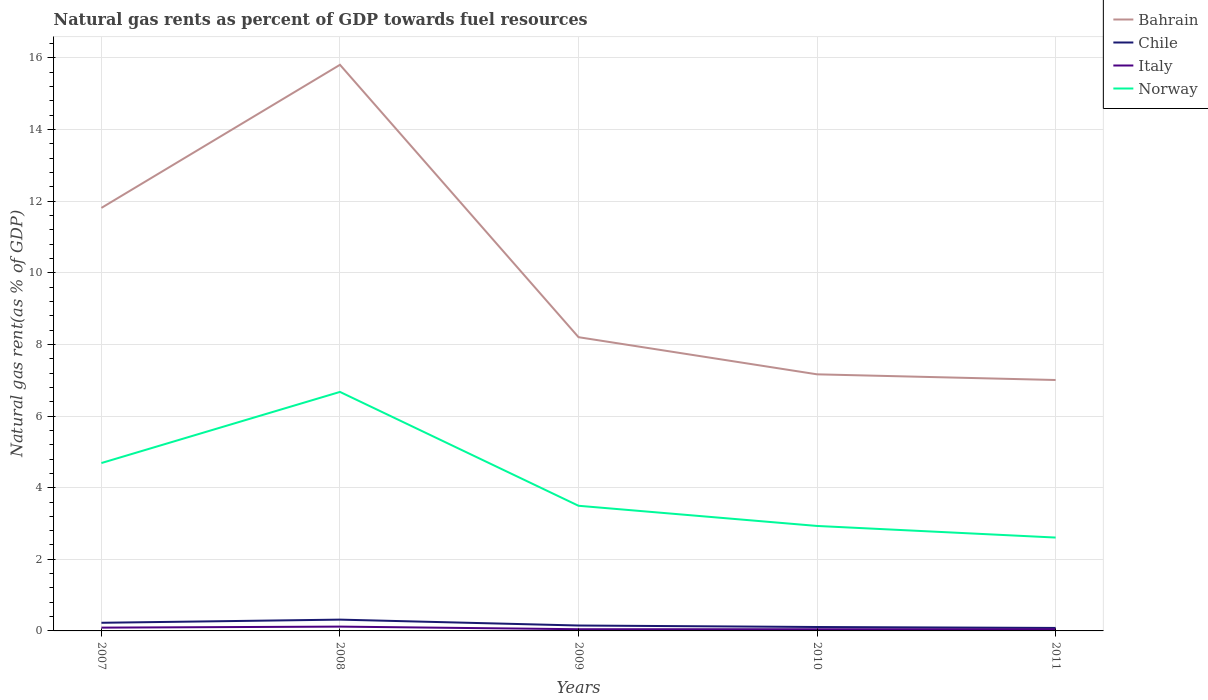Does the line corresponding to Italy intersect with the line corresponding to Bahrain?
Offer a terse response. No. Across all years, what is the maximum natural gas rent in Chile?
Offer a terse response. 0.08. In which year was the natural gas rent in Norway maximum?
Offer a terse response. 2011. What is the total natural gas rent in Chile in the graph?
Offer a terse response. 0.14. What is the difference between the highest and the second highest natural gas rent in Norway?
Give a very brief answer. 4.07. Is the natural gas rent in Chile strictly greater than the natural gas rent in Italy over the years?
Give a very brief answer. No. How many lines are there?
Keep it short and to the point. 4. Are the values on the major ticks of Y-axis written in scientific E-notation?
Your answer should be very brief. No. Does the graph contain any zero values?
Make the answer very short. No. Does the graph contain grids?
Your response must be concise. Yes. How are the legend labels stacked?
Make the answer very short. Vertical. What is the title of the graph?
Give a very brief answer. Natural gas rents as percent of GDP towards fuel resources. What is the label or title of the Y-axis?
Your response must be concise. Natural gas rent(as % of GDP). What is the Natural gas rent(as % of GDP) of Bahrain in 2007?
Your answer should be compact. 11.81. What is the Natural gas rent(as % of GDP) in Chile in 2007?
Your answer should be compact. 0.23. What is the Natural gas rent(as % of GDP) of Italy in 2007?
Offer a terse response. 0.09. What is the Natural gas rent(as % of GDP) of Norway in 2007?
Your answer should be compact. 4.69. What is the Natural gas rent(as % of GDP) of Bahrain in 2008?
Provide a succinct answer. 15.81. What is the Natural gas rent(as % of GDP) of Chile in 2008?
Give a very brief answer. 0.32. What is the Natural gas rent(as % of GDP) in Italy in 2008?
Keep it short and to the point. 0.12. What is the Natural gas rent(as % of GDP) of Norway in 2008?
Provide a succinct answer. 6.67. What is the Natural gas rent(as % of GDP) in Bahrain in 2009?
Give a very brief answer. 8.2. What is the Natural gas rent(as % of GDP) of Chile in 2009?
Your response must be concise. 0.15. What is the Natural gas rent(as % of GDP) of Italy in 2009?
Your response must be concise. 0.05. What is the Natural gas rent(as % of GDP) in Norway in 2009?
Make the answer very short. 3.49. What is the Natural gas rent(as % of GDP) in Bahrain in 2010?
Offer a very short reply. 7.17. What is the Natural gas rent(as % of GDP) in Chile in 2010?
Keep it short and to the point. 0.11. What is the Natural gas rent(as % of GDP) of Italy in 2010?
Provide a short and direct response. 0.05. What is the Natural gas rent(as % of GDP) in Norway in 2010?
Your response must be concise. 2.93. What is the Natural gas rent(as % of GDP) in Bahrain in 2011?
Ensure brevity in your answer.  7.01. What is the Natural gas rent(as % of GDP) of Chile in 2011?
Keep it short and to the point. 0.08. What is the Natural gas rent(as % of GDP) in Italy in 2011?
Your answer should be very brief. 0.05. What is the Natural gas rent(as % of GDP) of Norway in 2011?
Offer a very short reply. 2.61. Across all years, what is the maximum Natural gas rent(as % of GDP) in Bahrain?
Offer a terse response. 15.81. Across all years, what is the maximum Natural gas rent(as % of GDP) in Chile?
Ensure brevity in your answer.  0.32. Across all years, what is the maximum Natural gas rent(as % of GDP) of Italy?
Your answer should be very brief. 0.12. Across all years, what is the maximum Natural gas rent(as % of GDP) of Norway?
Your answer should be compact. 6.67. Across all years, what is the minimum Natural gas rent(as % of GDP) in Bahrain?
Your answer should be compact. 7.01. Across all years, what is the minimum Natural gas rent(as % of GDP) of Chile?
Your answer should be compact. 0.08. Across all years, what is the minimum Natural gas rent(as % of GDP) in Italy?
Ensure brevity in your answer.  0.05. Across all years, what is the minimum Natural gas rent(as % of GDP) of Norway?
Ensure brevity in your answer.  2.61. What is the total Natural gas rent(as % of GDP) of Bahrain in the graph?
Provide a short and direct response. 50. What is the total Natural gas rent(as % of GDP) of Chile in the graph?
Ensure brevity in your answer.  0.89. What is the total Natural gas rent(as % of GDP) of Italy in the graph?
Your answer should be compact. 0.35. What is the total Natural gas rent(as % of GDP) in Norway in the graph?
Your answer should be very brief. 20.4. What is the difference between the Natural gas rent(as % of GDP) in Bahrain in 2007 and that in 2008?
Keep it short and to the point. -4. What is the difference between the Natural gas rent(as % of GDP) in Chile in 2007 and that in 2008?
Keep it short and to the point. -0.09. What is the difference between the Natural gas rent(as % of GDP) of Italy in 2007 and that in 2008?
Keep it short and to the point. -0.03. What is the difference between the Natural gas rent(as % of GDP) of Norway in 2007 and that in 2008?
Your answer should be very brief. -1.99. What is the difference between the Natural gas rent(as % of GDP) of Bahrain in 2007 and that in 2009?
Your answer should be compact. 3.61. What is the difference between the Natural gas rent(as % of GDP) of Chile in 2007 and that in 2009?
Make the answer very short. 0.08. What is the difference between the Natural gas rent(as % of GDP) of Italy in 2007 and that in 2009?
Your answer should be compact. 0.04. What is the difference between the Natural gas rent(as % of GDP) in Norway in 2007 and that in 2009?
Ensure brevity in your answer.  1.19. What is the difference between the Natural gas rent(as % of GDP) of Bahrain in 2007 and that in 2010?
Your answer should be compact. 4.65. What is the difference between the Natural gas rent(as % of GDP) in Chile in 2007 and that in 2010?
Give a very brief answer. 0.12. What is the difference between the Natural gas rent(as % of GDP) in Italy in 2007 and that in 2010?
Provide a succinct answer. 0.05. What is the difference between the Natural gas rent(as % of GDP) of Norway in 2007 and that in 2010?
Your answer should be compact. 1.76. What is the difference between the Natural gas rent(as % of GDP) of Bahrain in 2007 and that in 2011?
Keep it short and to the point. 4.81. What is the difference between the Natural gas rent(as % of GDP) in Chile in 2007 and that in 2011?
Provide a succinct answer. 0.14. What is the difference between the Natural gas rent(as % of GDP) of Italy in 2007 and that in 2011?
Your answer should be compact. 0.04. What is the difference between the Natural gas rent(as % of GDP) in Norway in 2007 and that in 2011?
Offer a very short reply. 2.08. What is the difference between the Natural gas rent(as % of GDP) in Bahrain in 2008 and that in 2009?
Your response must be concise. 7.61. What is the difference between the Natural gas rent(as % of GDP) of Chile in 2008 and that in 2009?
Give a very brief answer. 0.16. What is the difference between the Natural gas rent(as % of GDP) in Italy in 2008 and that in 2009?
Keep it short and to the point. 0.07. What is the difference between the Natural gas rent(as % of GDP) in Norway in 2008 and that in 2009?
Provide a short and direct response. 3.18. What is the difference between the Natural gas rent(as % of GDP) of Bahrain in 2008 and that in 2010?
Ensure brevity in your answer.  8.64. What is the difference between the Natural gas rent(as % of GDP) of Chile in 2008 and that in 2010?
Ensure brevity in your answer.  0.21. What is the difference between the Natural gas rent(as % of GDP) in Italy in 2008 and that in 2010?
Keep it short and to the point. 0.07. What is the difference between the Natural gas rent(as % of GDP) in Norway in 2008 and that in 2010?
Make the answer very short. 3.74. What is the difference between the Natural gas rent(as % of GDP) of Bahrain in 2008 and that in 2011?
Provide a succinct answer. 8.8. What is the difference between the Natural gas rent(as % of GDP) of Chile in 2008 and that in 2011?
Offer a terse response. 0.23. What is the difference between the Natural gas rent(as % of GDP) of Italy in 2008 and that in 2011?
Provide a short and direct response. 0.07. What is the difference between the Natural gas rent(as % of GDP) of Norway in 2008 and that in 2011?
Provide a short and direct response. 4.07. What is the difference between the Natural gas rent(as % of GDP) in Bahrain in 2009 and that in 2010?
Your answer should be compact. 1.04. What is the difference between the Natural gas rent(as % of GDP) of Chile in 2009 and that in 2010?
Offer a very short reply. 0.04. What is the difference between the Natural gas rent(as % of GDP) in Italy in 2009 and that in 2010?
Your answer should be very brief. 0. What is the difference between the Natural gas rent(as % of GDP) in Norway in 2009 and that in 2010?
Offer a very short reply. 0.56. What is the difference between the Natural gas rent(as % of GDP) in Bahrain in 2009 and that in 2011?
Provide a short and direct response. 1.2. What is the difference between the Natural gas rent(as % of GDP) in Chile in 2009 and that in 2011?
Provide a short and direct response. 0.07. What is the difference between the Natural gas rent(as % of GDP) of Italy in 2009 and that in 2011?
Offer a terse response. 0. What is the difference between the Natural gas rent(as % of GDP) of Norway in 2009 and that in 2011?
Offer a very short reply. 0.89. What is the difference between the Natural gas rent(as % of GDP) in Bahrain in 2010 and that in 2011?
Offer a very short reply. 0.16. What is the difference between the Natural gas rent(as % of GDP) in Chile in 2010 and that in 2011?
Your answer should be compact. 0.03. What is the difference between the Natural gas rent(as % of GDP) of Italy in 2010 and that in 2011?
Your response must be concise. -0. What is the difference between the Natural gas rent(as % of GDP) in Norway in 2010 and that in 2011?
Provide a succinct answer. 0.32. What is the difference between the Natural gas rent(as % of GDP) of Bahrain in 2007 and the Natural gas rent(as % of GDP) of Chile in 2008?
Make the answer very short. 11.5. What is the difference between the Natural gas rent(as % of GDP) of Bahrain in 2007 and the Natural gas rent(as % of GDP) of Italy in 2008?
Offer a very short reply. 11.69. What is the difference between the Natural gas rent(as % of GDP) of Bahrain in 2007 and the Natural gas rent(as % of GDP) of Norway in 2008?
Offer a terse response. 5.14. What is the difference between the Natural gas rent(as % of GDP) in Chile in 2007 and the Natural gas rent(as % of GDP) in Italy in 2008?
Your answer should be very brief. 0.11. What is the difference between the Natural gas rent(as % of GDP) in Chile in 2007 and the Natural gas rent(as % of GDP) in Norway in 2008?
Ensure brevity in your answer.  -6.45. What is the difference between the Natural gas rent(as % of GDP) in Italy in 2007 and the Natural gas rent(as % of GDP) in Norway in 2008?
Provide a succinct answer. -6.58. What is the difference between the Natural gas rent(as % of GDP) of Bahrain in 2007 and the Natural gas rent(as % of GDP) of Chile in 2009?
Ensure brevity in your answer.  11.66. What is the difference between the Natural gas rent(as % of GDP) in Bahrain in 2007 and the Natural gas rent(as % of GDP) in Italy in 2009?
Ensure brevity in your answer.  11.77. What is the difference between the Natural gas rent(as % of GDP) of Bahrain in 2007 and the Natural gas rent(as % of GDP) of Norway in 2009?
Give a very brief answer. 8.32. What is the difference between the Natural gas rent(as % of GDP) of Chile in 2007 and the Natural gas rent(as % of GDP) of Italy in 2009?
Keep it short and to the point. 0.18. What is the difference between the Natural gas rent(as % of GDP) in Chile in 2007 and the Natural gas rent(as % of GDP) in Norway in 2009?
Give a very brief answer. -3.27. What is the difference between the Natural gas rent(as % of GDP) of Italy in 2007 and the Natural gas rent(as % of GDP) of Norway in 2009?
Your answer should be very brief. -3.4. What is the difference between the Natural gas rent(as % of GDP) in Bahrain in 2007 and the Natural gas rent(as % of GDP) in Chile in 2010?
Give a very brief answer. 11.7. What is the difference between the Natural gas rent(as % of GDP) of Bahrain in 2007 and the Natural gas rent(as % of GDP) of Italy in 2010?
Give a very brief answer. 11.77. What is the difference between the Natural gas rent(as % of GDP) of Bahrain in 2007 and the Natural gas rent(as % of GDP) of Norway in 2010?
Offer a terse response. 8.88. What is the difference between the Natural gas rent(as % of GDP) in Chile in 2007 and the Natural gas rent(as % of GDP) in Italy in 2010?
Ensure brevity in your answer.  0.18. What is the difference between the Natural gas rent(as % of GDP) in Chile in 2007 and the Natural gas rent(as % of GDP) in Norway in 2010?
Make the answer very short. -2.7. What is the difference between the Natural gas rent(as % of GDP) in Italy in 2007 and the Natural gas rent(as % of GDP) in Norway in 2010?
Give a very brief answer. -2.84. What is the difference between the Natural gas rent(as % of GDP) of Bahrain in 2007 and the Natural gas rent(as % of GDP) of Chile in 2011?
Ensure brevity in your answer.  11.73. What is the difference between the Natural gas rent(as % of GDP) in Bahrain in 2007 and the Natural gas rent(as % of GDP) in Italy in 2011?
Offer a terse response. 11.77. What is the difference between the Natural gas rent(as % of GDP) in Bahrain in 2007 and the Natural gas rent(as % of GDP) in Norway in 2011?
Your answer should be very brief. 9.21. What is the difference between the Natural gas rent(as % of GDP) in Chile in 2007 and the Natural gas rent(as % of GDP) in Italy in 2011?
Provide a succinct answer. 0.18. What is the difference between the Natural gas rent(as % of GDP) in Chile in 2007 and the Natural gas rent(as % of GDP) in Norway in 2011?
Provide a succinct answer. -2.38. What is the difference between the Natural gas rent(as % of GDP) of Italy in 2007 and the Natural gas rent(as % of GDP) of Norway in 2011?
Your response must be concise. -2.52. What is the difference between the Natural gas rent(as % of GDP) of Bahrain in 2008 and the Natural gas rent(as % of GDP) of Chile in 2009?
Provide a succinct answer. 15.66. What is the difference between the Natural gas rent(as % of GDP) of Bahrain in 2008 and the Natural gas rent(as % of GDP) of Italy in 2009?
Give a very brief answer. 15.76. What is the difference between the Natural gas rent(as % of GDP) in Bahrain in 2008 and the Natural gas rent(as % of GDP) in Norway in 2009?
Offer a very short reply. 12.31. What is the difference between the Natural gas rent(as % of GDP) of Chile in 2008 and the Natural gas rent(as % of GDP) of Italy in 2009?
Keep it short and to the point. 0.27. What is the difference between the Natural gas rent(as % of GDP) of Chile in 2008 and the Natural gas rent(as % of GDP) of Norway in 2009?
Provide a short and direct response. -3.18. What is the difference between the Natural gas rent(as % of GDP) of Italy in 2008 and the Natural gas rent(as % of GDP) of Norway in 2009?
Provide a succinct answer. -3.37. What is the difference between the Natural gas rent(as % of GDP) in Bahrain in 2008 and the Natural gas rent(as % of GDP) in Chile in 2010?
Offer a very short reply. 15.7. What is the difference between the Natural gas rent(as % of GDP) of Bahrain in 2008 and the Natural gas rent(as % of GDP) of Italy in 2010?
Make the answer very short. 15.76. What is the difference between the Natural gas rent(as % of GDP) of Bahrain in 2008 and the Natural gas rent(as % of GDP) of Norway in 2010?
Ensure brevity in your answer.  12.88. What is the difference between the Natural gas rent(as % of GDP) in Chile in 2008 and the Natural gas rent(as % of GDP) in Italy in 2010?
Offer a very short reply. 0.27. What is the difference between the Natural gas rent(as % of GDP) of Chile in 2008 and the Natural gas rent(as % of GDP) of Norway in 2010?
Provide a short and direct response. -2.62. What is the difference between the Natural gas rent(as % of GDP) of Italy in 2008 and the Natural gas rent(as % of GDP) of Norway in 2010?
Make the answer very short. -2.81. What is the difference between the Natural gas rent(as % of GDP) of Bahrain in 2008 and the Natural gas rent(as % of GDP) of Chile in 2011?
Ensure brevity in your answer.  15.73. What is the difference between the Natural gas rent(as % of GDP) of Bahrain in 2008 and the Natural gas rent(as % of GDP) of Italy in 2011?
Provide a succinct answer. 15.76. What is the difference between the Natural gas rent(as % of GDP) of Bahrain in 2008 and the Natural gas rent(as % of GDP) of Norway in 2011?
Your response must be concise. 13.2. What is the difference between the Natural gas rent(as % of GDP) of Chile in 2008 and the Natural gas rent(as % of GDP) of Italy in 2011?
Provide a short and direct response. 0.27. What is the difference between the Natural gas rent(as % of GDP) in Chile in 2008 and the Natural gas rent(as % of GDP) in Norway in 2011?
Provide a succinct answer. -2.29. What is the difference between the Natural gas rent(as % of GDP) of Italy in 2008 and the Natural gas rent(as % of GDP) of Norway in 2011?
Offer a very short reply. -2.49. What is the difference between the Natural gas rent(as % of GDP) of Bahrain in 2009 and the Natural gas rent(as % of GDP) of Chile in 2010?
Give a very brief answer. 8.09. What is the difference between the Natural gas rent(as % of GDP) in Bahrain in 2009 and the Natural gas rent(as % of GDP) in Italy in 2010?
Offer a terse response. 8.16. What is the difference between the Natural gas rent(as % of GDP) in Bahrain in 2009 and the Natural gas rent(as % of GDP) in Norway in 2010?
Your response must be concise. 5.27. What is the difference between the Natural gas rent(as % of GDP) in Chile in 2009 and the Natural gas rent(as % of GDP) in Italy in 2010?
Provide a short and direct response. 0.1. What is the difference between the Natural gas rent(as % of GDP) of Chile in 2009 and the Natural gas rent(as % of GDP) of Norway in 2010?
Your answer should be compact. -2.78. What is the difference between the Natural gas rent(as % of GDP) of Italy in 2009 and the Natural gas rent(as % of GDP) of Norway in 2010?
Your answer should be very brief. -2.88. What is the difference between the Natural gas rent(as % of GDP) of Bahrain in 2009 and the Natural gas rent(as % of GDP) of Chile in 2011?
Your answer should be compact. 8.12. What is the difference between the Natural gas rent(as % of GDP) of Bahrain in 2009 and the Natural gas rent(as % of GDP) of Italy in 2011?
Offer a terse response. 8.16. What is the difference between the Natural gas rent(as % of GDP) in Bahrain in 2009 and the Natural gas rent(as % of GDP) in Norway in 2011?
Offer a terse response. 5.6. What is the difference between the Natural gas rent(as % of GDP) in Chile in 2009 and the Natural gas rent(as % of GDP) in Italy in 2011?
Your response must be concise. 0.1. What is the difference between the Natural gas rent(as % of GDP) of Chile in 2009 and the Natural gas rent(as % of GDP) of Norway in 2011?
Give a very brief answer. -2.46. What is the difference between the Natural gas rent(as % of GDP) of Italy in 2009 and the Natural gas rent(as % of GDP) of Norway in 2011?
Offer a very short reply. -2.56. What is the difference between the Natural gas rent(as % of GDP) of Bahrain in 2010 and the Natural gas rent(as % of GDP) of Chile in 2011?
Offer a terse response. 7.08. What is the difference between the Natural gas rent(as % of GDP) in Bahrain in 2010 and the Natural gas rent(as % of GDP) in Italy in 2011?
Ensure brevity in your answer.  7.12. What is the difference between the Natural gas rent(as % of GDP) in Bahrain in 2010 and the Natural gas rent(as % of GDP) in Norway in 2011?
Ensure brevity in your answer.  4.56. What is the difference between the Natural gas rent(as % of GDP) of Chile in 2010 and the Natural gas rent(as % of GDP) of Italy in 2011?
Your answer should be compact. 0.06. What is the difference between the Natural gas rent(as % of GDP) of Chile in 2010 and the Natural gas rent(as % of GDP) of Norway in 2011?
Ensure brevity in your answer.  -2.5. What is the difference between the Natural gas rent(as % of GDP) of Italy in 2010 and the Natural gas rent(as % of GDP) of Norway in 2011?
Ensure brevity in your answer.  -2.56. What is the average Natural gas rent(as % of GDP) in Bahrain per year?
Provide a succinct answer. 10. What is the average Natural gas rent(as % of GDP) of Chile per year?
Give a very brief answer. 0.18. What is the average Natural gas rent(as % of GDP) in Italy per year?
Your answer should be compact. 0.07. What is the average Natural gas rent(as % of GDP) in Norway per year?
Your answer should be compact. 4.08. In the year 2007, what is the difference between the Natural gas rent(as % of GDP) in Bahrain and Natural gas rent(as % of GDP) in Chile?
Your answer should be compact. 11.59. In the year 2007, what is the difference between the Natural gas rent(as % of GDP) of Bahrain and Natural gas rent(as % of GDP) of Italy?
Keep it short and to the point. 11.72. In the year 2007, what is the difference between the Natural gas rent(as % of GDP) of Bahrain and Natural gas rent(as % of GDP) of Norway?
Your response must be concise. 7.13. In the year 2007, what is the difference between the Natural gas rent(as % of GDP) of Chile and Natural gas rent(as % of GDP) of Italy?
Provide a short and direct response. 0.13. In the year 2007, what is the difference between the Natural gas rent(as % of GDP) in Chile and Natural gas rent(as % of GDP) in Norway?
Make the answer very short. -4.46. In the year 2007, what is the difference between the Natural gas rent(as % of GDP) in Italy and Natural gas rent(as % of GDP) in Norway?
Make the answer very short. -4.6. In the year 2008, what is the difference between the Natural gas rent(as % of GDP) of Bahrain and Natural gas rent(as % of GDP) of Chile?
Give a very brief answer. 15.49. In the year 2008, what is the difference between the Natural gas rent(as % of GDP) in Bahrain and Natural gas rent(as % of GDP) in Italy?
Offer a terse response. 15.69. In the year 2008, what is the difference between the Natural gas rent(as % of GDP) of Bahrain and Natural gas rent(as % of GDP) of Norway?
Provide a succinct answer. 9.14. In the year 2008, what is the difference between the Natural gas rent(as % of GDP) in Chile and Natural gas rent(as % of GDP) in Italy?
Make the answer very short. 0.2. In the year 2008, what is the difference between the Natural gas rent(as % of GDP) in Chile and Natural gas rent(as % of GDP) in Norway?
Give a very brief answer. -6.36. In the year 2008, what is the difference between the Natural gas rent(as % of GDP) in Italy and Natural gas rent(as % of GDP) in Norway?
Make the answer very short. -6.55. In the year 2009, what is the difference between the Natural gas rent(as % of GDP) in Bahrain and Natural gas rent(as % of GDP) in Chile?
Provide a short and direct response. 8.05. In the year 2009, what is the difference between the Natural gas rent(as % of GDP) of Bahrain and Natural gas rent(as % of GDP) of Italy?
Your answer should be very brief. 8.16. In the year 2009, what is the difference between the Natural gas rent(as % of GDP) of Bahrain and Natural gas rent(as % of GDP) of Norway?
Your answer should be very brief. 4.71. In the year 2009, what is the difference between the Natural gas rent(as % of GDP) of Chile and Natural gas rent(as % of GDP) of Italy?
Your answer should be compact. 0.1. In the year 2009, what is the difference between the Natural gas rent(as % of GDP) in Chile and Natural gas rent(as % of GDP) in Norway?
Provide a short and direct response. -3.34. In the year 2009, what is the difference between the Natural gas rent(as % of GDP) in Italy and Natural gas rent(as % of GDP) in Norway?
Your answer should be very brief. -3.45. In the year 2010, what is the difference between the Natural gas rent(as % of GDP) of Bahrain and Natural gas rent(as % of GDP) of Chile?
Offer a very short reply. 7.06. In the year 2010, what is the difference between the Natural gas rent(as % of GDP) of Bahrain and Natural gas rent(as % of GDP) of Italy?
Your response must be concise. 7.12. In the year 2010, what is the difference between the Natural gas rent(as % of GDP) in Bahrain and Natural gas rent(as % of GDP) in Norway?
Keep it short and to the point. 4.23. In the year 2010, what is the difference between the Natural gas rent(as % of GDP) in Chile and Natural gas rent(as % of GDP) in Italy?
Keep it short and to the point. 0.06. In the year 2010, what is the difference between the Natural gas rent(as % of GDP) of Chile and Natural gas rent(as % of GDP) of Norway?
Ensure brevity in your answer.  -2.82. In the year 2010, what is the difference between the Natural gas rent(as % of GDP) of Italy and Natural gas rent(as % of GDP) of Norway?
Make the answer very short. -2.88. In the year 2011, what is the difference between the Natural gas rent(as % of GDP) of Bahrain and Natural gas rent(as % of GDP) of Chile?
Offer a terse response. 6.92. In the year 2011, what is the difference between the Natural gas rent(as % of GDP) of Bahrain and Natural gas rent(as % of GDP) of Italy?
Your answer should be very brief. 6.96. In the year 2011, what is the difference between the Natural gas rent(as % of GDP) in Bahrain and Natural gas rent(as % of GDP) in Norway?
Give a very brief answer. 4.4. In the year 2011, what is the difference between the Natural gas rent(as % of GDP) of Chile and Natural gas rent(as % of GDP) of Italy?
Provide a short and direct response. 0.04. In the year 2011, what is the difference between the Natural gas rent(as % of GDP) of Chile and Natural gas rent(as % of GDP) of Norway?
Ensure brevity in your answer.  -2.52. In the year 2011, what is the difference between the Natural gas rent(as % of GDP) in Italy and Natural gas rent(as % of GDP) in Norway?
Your answer should be very brief. -2.56. What is the ratio of the Natural gas rent(as % of GDP) in Bahrain in 2007 to that in 2008?
Ensure brevity in your answer.  0.75. What is the ratio of the Natural gas rent(as % of GDP) of Chile in 2007 to that in 2008?
Your answer should be compact. 0.72. What is the ratio of the Natural gas rent(as % of GDP) of Italy in 2007 to that in 2008?
Provide a succinct answer. 0.77. What is the ratio of the Natural gas rent(as % of GDP) in Norway in 2007 to that in 2008?
Your answer should be very brief. 0.7. What is the ratio of the Natural gas rent(as % of GDP) of Bahrain in 2007 to that in 2009?
Provide a short and direct response. 1.44. What is the ratio of the Natural gas rent(as % of GDP) of Chile in 2007 to that in 2009?
Make the answer very short. 1.51. What is the ratio of the Natural gas rent(as % of GDP) of Italy in 2007 to that in 2009?
Your response must be concise. 1.93. What is the ratio of the Natural gas rent(as % of GDP) in Norway in 2007 to that in 2009?
Offer a very short reply. 1.34. What is the ratio of the Natural gas rent(as % of GDP) of Bahrain in 2007 to that in 2010?
Keep it short and to the point. 1.65. What is the ratio of the Natural gas rent(as % of GDP) of Chile in 2007 to that in 2010?
Your response must be concise. 2.08. What is the ratio of the Natural gas rent(as % of GDP) in Italy in 2007 to that in 2010?
Provide a succinct answer. 1.98. What is the ratio of the Natural gas rent(as % of GDP) of Norway in 2007 to that in 2010?
Ensure brevity in your answer.  1.6. What is the ratio of the Natural gas rent(as % of GDP) of Bahrain in 2007 to that in 2011?
Your response must be concise. 1.69. What is the ratio of the Natural gas rent(as % of GDP) of Chile in 2007 to that in 2011?
Keep it short and to the point. 2.73. What is the ratio of the Natural gas rent(as % of GDP) of Italy in 2007 to that in 2011?
Your answer should be very brief. 1.94. What is the ratio of the Natural gas rent(as % of GDP) in Norway in 2007 to that in 2011?
Offer a very short reply. 1.8. What is the ratio of the Natural gas rent(as % of GDP) of Bahrain in 2008 to that in 2009?
Your answer should be compact. 1.93. What is the ratio of the Natural gas rent(as % of GDP) of Chile in 2008 to that in 2009?
Your answer should be compact. 2.09. What is the ratio of the Natural gas rent(as % of GDP) in Italy in 2008 to that in 2009?
Your response must be concise. 2.52. What is the ratio of the Natural gas rent(as % of GDP) of Norway in 2008 to that in 2009?
Offer a terse response. 1.91. What is the ratio of the Natural gas rent(as % of GDP) in Bahrain in 2008 to that in 2010?
Your answer should be compact. 2.21. What is the ratio of the Natural gas rent(as % of GDP) of Chile in 2008 to that in 2010?
Your response must be concise. 2.89. What is the ratio of the Natural gas rent(as % of GDP) of Italy in 2008 to that in 2010?
Provide a short and direct response. 2.58. What is the ratio of the Natural gas rent(as % of GDP) in Norway in 2008 to that in 2010?
Provide a succinct answer. 2.28. What is the ratio of the Natural gas rent(as % of GDP) in Bahrain in 2008 to that in 2011?
Offer a very short reply. 2.26. What is the ratio of the Natural gas rent(as % of GDP) in Chile in 2008 to that in 2011?
Your response must be concise. 3.79. What is the ratio of the Natural gas rent(as % of GDP) in Italy in 2008 to that in 2011?
Keep it short and to the point. 2.53. What is the ratio of the Natural gas rent(as % of GDP) in Norway in 2008 to that in 2011?
Make the answer very short. 2.56. What is the ratio of the Natural gas rent(as % of GDP) of Bahrain in 2009 to that in 2010?
Provide a short and direct response. 1.14. What is the ratio of the Natural gas rent(as % of GDP) in Chile in 2009 to that in 2010?
Your answer should be very brief. 1.38. What is the ratio of the Natural gas rent(as % of GDP) in Italy in 2009 to that in 2010?
Offer a very short reply. 1.02. What is the ratio of the Natural gas rent(as % of GDP) in Norway in 2009 to that in 2010?
Your answer should be compact. 1.19. What is the ratio of the Natural gas rent(as % of GDP) in Bahrain in 2009 to that in 2011?
Offer a terse response. 1.17. What is the ratio of the Natural gas rent(as % of GDP) in Chile in 2009 to that in 2011?
Make the answer very short. 1.81. What is the ratio of the Natural gas rent(as % of GDP) of Norway in 2009 to that in 2011?
Offer a terse response. 1.34. What is the ratio of the Natural gas rent(as % of GDP) of Bahrain in 2010 to that in 2011?
Your answer should be compact. 1.02. What is the ratio of the Natural gas rent(as % of GDP) in Chile in 2010 to that in 2011?
Give a very brief answer. 1.31. What is the ratio of the Natural gas rent(as % of GDP) in Italy in 2010 to that in 2011?
Your answer should be compact. 0.98. What is the ratio of the Natural gas rent(as % of GDP) in Norway in 2010 to that in 2011?
Your response must be concise. 1.12. What is the difference between the highest and the second highest Natural gas rent(as % of GDP) in Bahrain?
Provide a short and direct response. 4. What is the difference between the highest and the second highest Natural gas rent(as % of GDP) of Chile?
Your answer should be compact. 0.09. What is the difference between the highest and the second highest Natural gas rent(as % of GDP) of Italy?
Offer a very short reply. 0.03. What is the difference between the highest and the second highest Natural gas rent(as % of GDP) of Norway?
Offer a terse response. 1.99. What is the difference between the highest and the lowest Natural gas rent(as % of GDP) of Bahrain?
Provide a short and direct response. 8.8. What is the difference between the highest and the lowest Natural gas rent(as % of GDP) of Chile?
Provide a short and direct response. 0.23. What is the difference between the highest and the lowest Natural gas rent(as % of GDP) of Italy?
Keep it short and to the point. 0.07. What is the difference between the highest and the lowest Natural gas rent(as % of GDP) of Norway?
Provide a short and direct response. 4.07. 